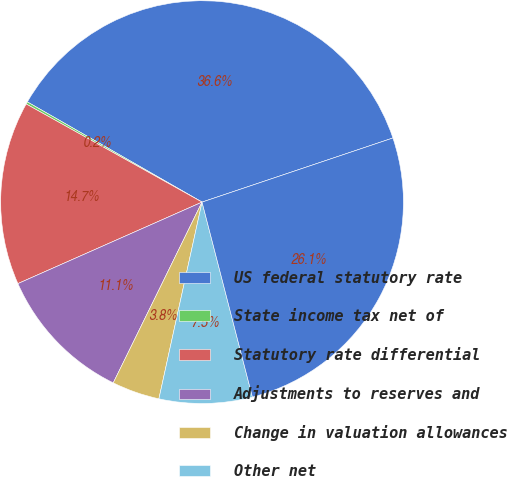Convert chart to OTSL. <chart><loc_0><loc_0><loc_500><loc_500><pie_chart><fcel>US federal statutory rate<fcel>State income tax net of<fcel>Statutory rate differential<fcel>Adjustments to reserves and<fcel>Change in valuation allowances<fcel>Other net<fcel>EFFECTIVE INCOME TAX RATE<nl><fcel>36.55%<fcel>0.19%<fcel>14.73%<fcel>11.1%<fcel>3.83%<fcel>7.46%<fcel>26.13%<nl></chart> 